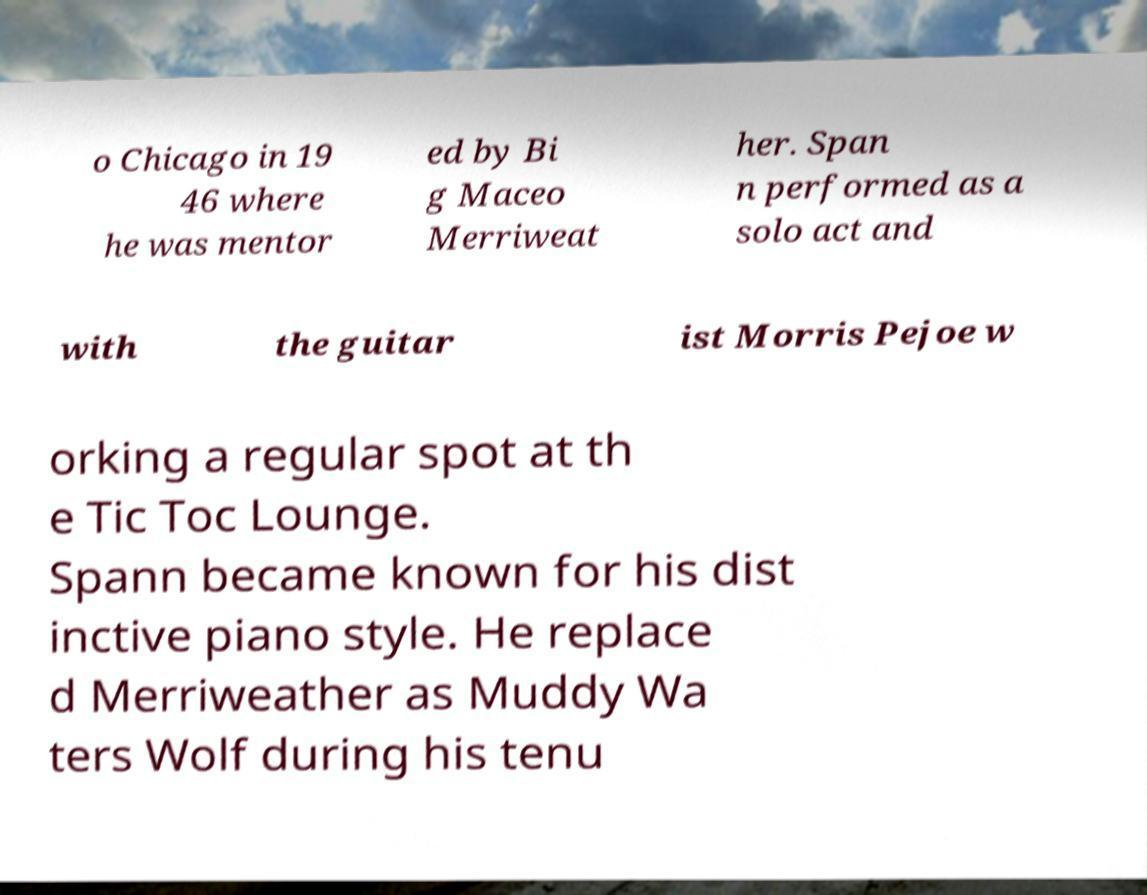There's text embedded in this image that I need extracted. Can you transcribe it verbatim? o Chicago in 19 46 where he was mentor ed by Bi g Maceo Merriweat her. Span n performed as a solo act and with the guitar ist Morris Pejoe w orking a regular spot at th e Tic Toc Lounge. Spann became known for his dist inctive piano style. He replace d Merriweather as Muddy Wa ters Wolf during his tenu 